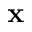Convert formula to latex. <formula><loc_0><loc_0><loc_500><loc_500>x</formula> 